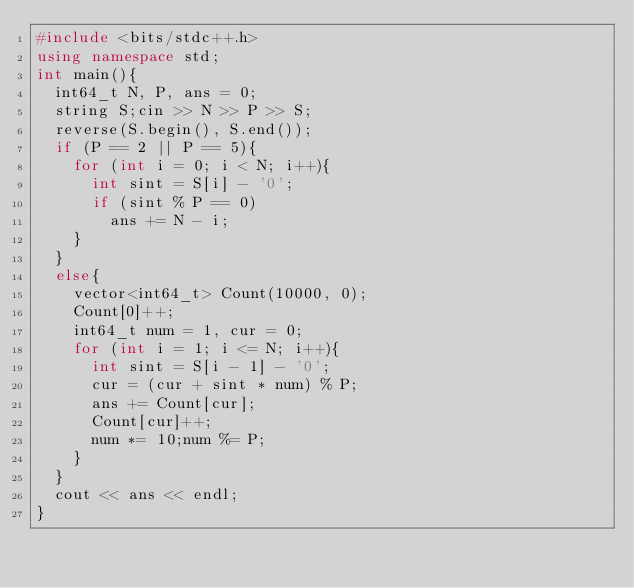Convert code to text. <code><loc_0><loc_0><loc_500><loc_500><_C++_>#include <bits/stdc++.h>
using namespace std;
int main(){
  int64_t N, P, ans = 0;
  string S;cin >> N >> P >> S;
  reverse(S.begin(), S.end());
  if (P == 2 || P == 5){
    for (int i = 0; i < N; i++){
      int sint = S[i] - '0';
      if (sint % P == 0)
        ans += N - i;
    }
  }
  else{
    vector<int64_t> Count(10000, 0);
    Count[0]++;
    int64_t num = 1, cur = 0;
    for (int i = 1; i <= N; i++){
      int sint = S[i - 1] - '0';
      cur = (cur + sint * num) % P;
      ans += Count[cur];
      Count[cur]++;
      num *= 10;num %= P;
    }
  }
  cout << ans << endl;
}</code> 